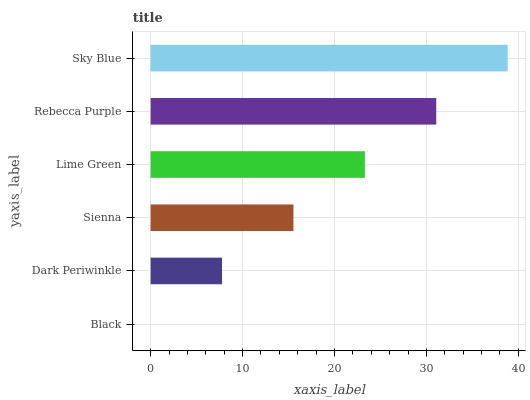Is Black the minimum?
Answer yes or no. Yes. Is Sky Blue the maximum?
Answer yes or no. Yes. Is Dark Periwinkle the minimum?
Answer yes or no. No. Is Dark Periwinkle the maximum?
Answer yes or no. No. Is Dark Periwinkle greater than Black?
Answer yes or no. Yes. Is Black less than Dark Periwinkle?
Answer yes or no. Yes. Is Black greater than Dark Periwinkle?
Answer yes or no. No. Is Dark Periwinkle less than Black?
Answer yes or no. No. Is Lime Green the high median?
Answer yes or no. Yes. Is Sienna the low median?
Answer yes or no. Yes. Is Dark Periwinkle the high median?
Answer yes or no. No. Is Black the low median?
Answer yes or no. No. 